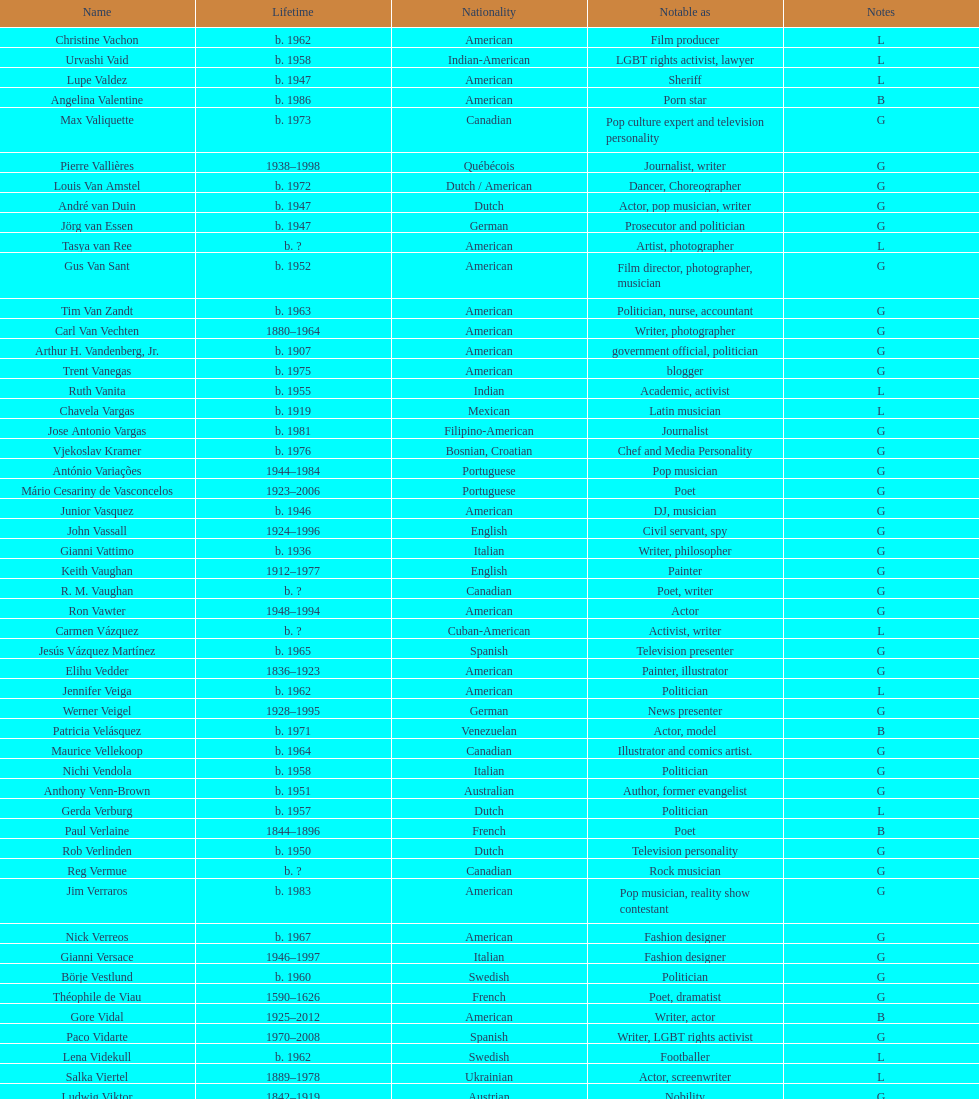Which nationality had the larger volume of names listed? American. 